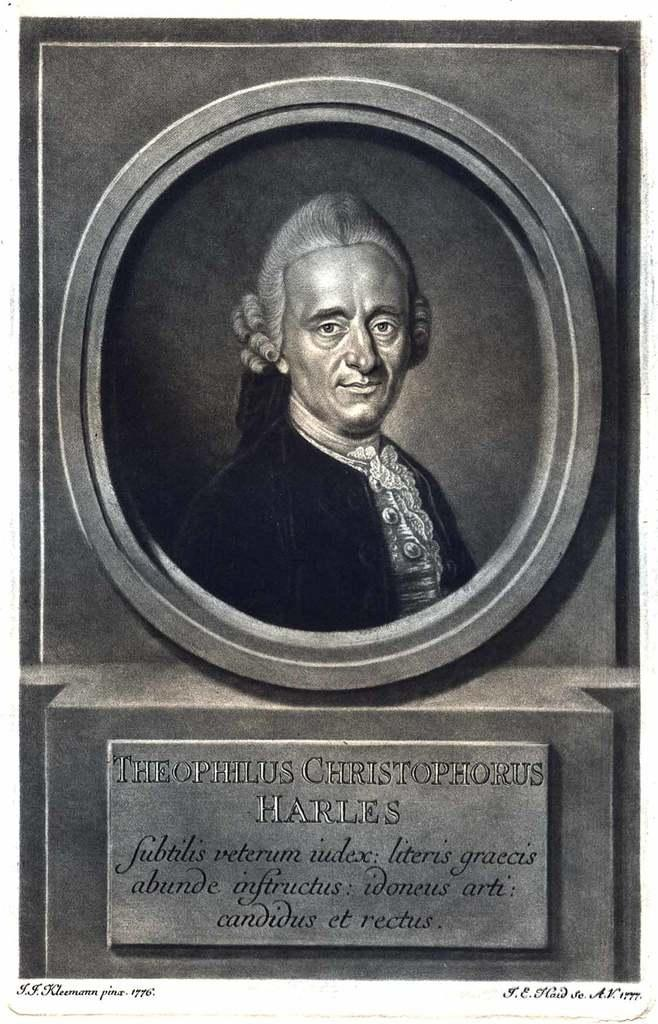What is located on the wall in the image? There is a statue on a wall in the image. What can be seen on a stone in the image? There is something written on a stone in the image. Where is the text located in the image? The text is visible at the bottom of the image. How many drawers are visible in the image? There are no drawers present in the image. What type of crow can be seen perched on the statue in the image? There is no crow present in the image; it only features a statue on a wall and text on a stone. 